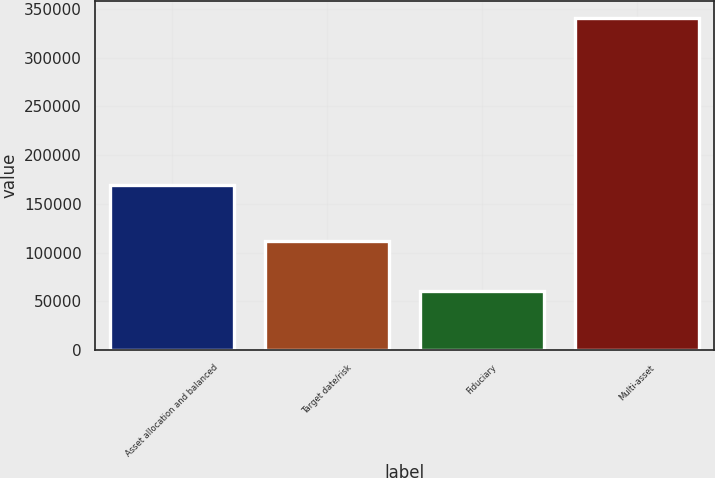Convert chart to OTSL. <chart><loc_0><loc_0><loc_500><loc_500><bar_chart><fcel>Asset allocation and balanced<fcel>Target date/risk<fcel>Fiduciary<fcel>Multi-asset<nl><fcel>169604<fcel>111408<fcel>60202<fcel>341214<nl></chart> 